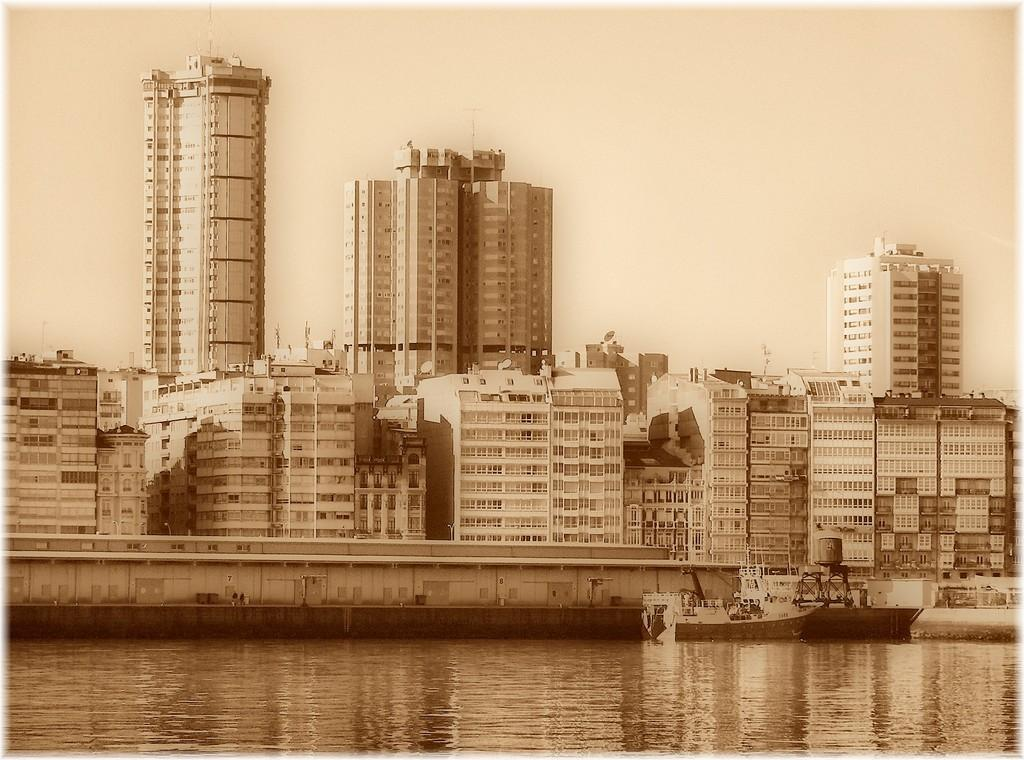What is the main subject of the image? The main subject of the image is a ship. Where is the ship located in the image? The ship is on the water in the image. What other structures can be seen in the image? There are buildings and antennas visible in the image. What part of the natural environment is visible in the image? The sky is visible in the image. What type of apparel is the jellyfish wearing in the image? There is no jellyfish present in the image, so it is not possible to determine what type of apparel it might be wearing. 